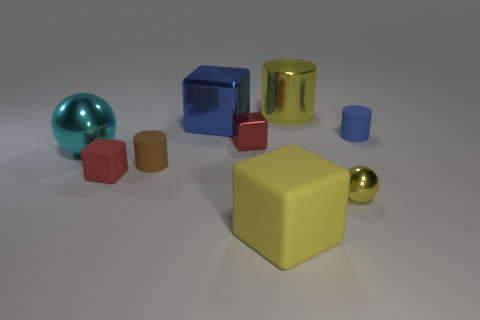How many other objects are there of the same material as the tiny brown cylinder?
Your response must be concise. 3. Is the color of the large metal block the same as the matte cylinder right of the big yellow rubber block?
Offer a very short reply. Yes. What number of big yellow things are behind the red shiny object?
Keep it short and to the point. 1. Are there fewer rubber cubes that are behind the tiny red matte cube than rubber objects?
Keep it short and to the point. Yes. The big shiny block is what color?
Ensure brevity in your answer.  Blue. Is the color of the big block in front of the small brown thing the same as the small rubber block?
Offer a terse response. No. There is another object that is the same shape as the large cyan object; what is its color?
Keep it short and to the point. Yellow. What number of large objects are brown cylinders or spheres?
Give a very brief answer. 1. There is a blue thing that is on the left side of the tiny blue rubber object; what is its size?
Your answer should be compact. Large. Is there a big rubber block that has the same color as the small metallic sphere?
Offer a very short reply. Yes. 